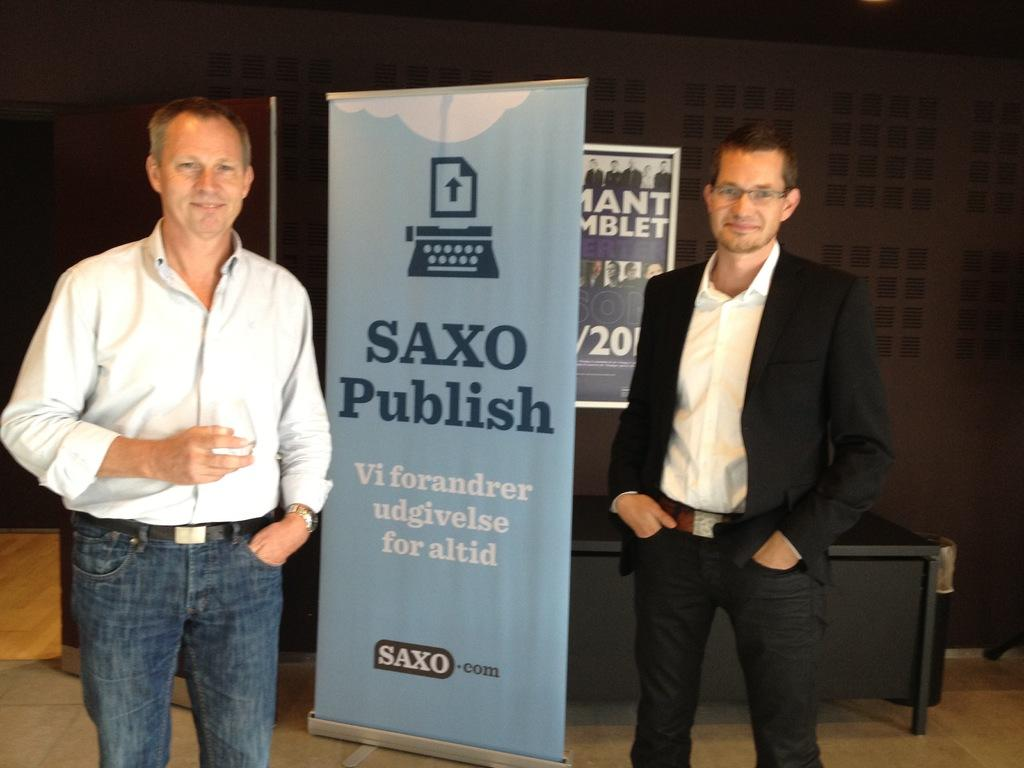How many people are present in the image? There are two persons standing in the image. What is one of the persons holding in the image? There is a person holding an object in the image. What can be seen hanging in the image? There is a banner in the image. What is a flat, raised surface visible in the image? There is a board in the image. What piece of furniture is present in the image? There is a table in the image. What architectural feature is present in the image? There is a door in the image. What type of flame can be seen coming from the street in the image? There is no flame or street present in the image. What is the purpose of the alarm in the image? There is no alarm present in the image. 